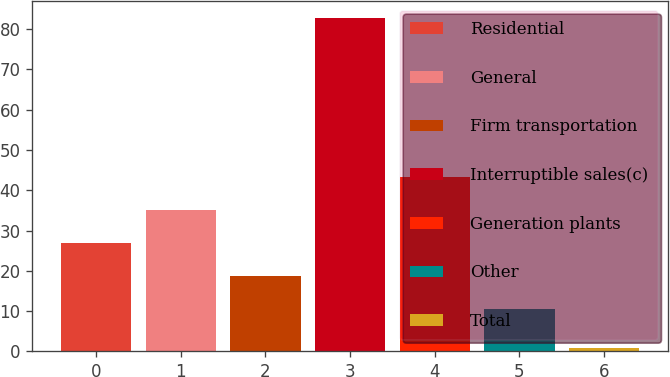Convert chart to OTSL. <chart><loc_0><loc_0><loc_500><loc_500><bar_chart><fcel>Residential<fcel>General<fcel>Firm transportation<fcel>Interruptible sales(c)<fcel>Generation plants<fcel>Other<fcel>Total<nl><fcel>27<fcel>35.2<fcel>18.8<fcel>82.9<fcel>43.4<fcel>10.6<fcel>0.9<nl></chart> 